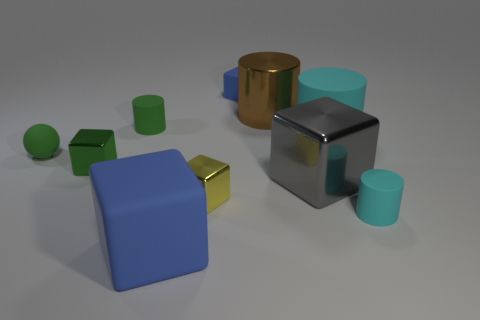Subtract all small green metallic cubes. How many cubes are left? 4 Subtract all blue blocks. How many blocks are left? 3 Subtract all gray cylinders. Subtract all cyan blocks. How many cylinders are left? 4 Subtract all spheres. How many objects are left? 9 Add 7 big gray metal things. How many big gray metal things are left? 8 Add 3 yellow things. How many yellow things exist? 4 Subtract 0 purple cylinders. How many objects are left? 10 Subtract all brown things. Subtract all large gray blocks. How many objects are left? 8 